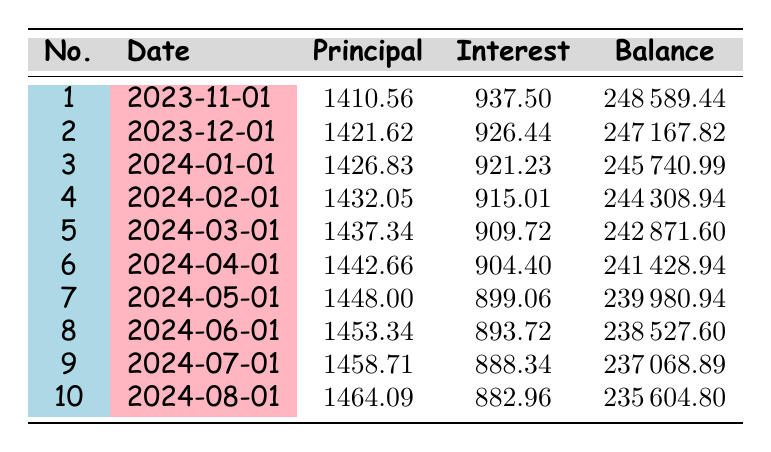What is the loan amount for the renovation? The loan amount is specifically stated in the loan details section, which indicates that the total amount borrowed is 250000.
Answer: 250000 What is the interest rate on the loan? The interest rate is also mentioned in the loan details, indicating that it is 4.5 percent.
Answer: 4.5 How much is the monthly payment? The monthly payment can be found in the loan details, which specifies that the payment amount is 1910.56.
Answer: 1910.56 Which payment number has the highest principal payment? To determine which payment number has the highest principal payment, we need to look at the principal payment column of the table. The payments increase each month, and by reviewing the data, the 10th payment is the highest at 1464.09.
Answer: 10 What is the total principal paid after the first three payments? We add the principal payments of the first three payments: 1410.56 + 1421.62 + 1426.83 = 4259.01.
Answer: 4259.01 Does the interest payment decrease with each payment? By examining the interest payment column, we notice that the amounts decrease each month, confirming that the interest payment becomes smaller over time as the principal is paid down.
Answer: Yes What is the remaining balance after the fifth payment? The remaining balance after the fifth payment can be found in the table, which lists 242871.60 as the balance after the fifth payment.
Answer: 242871.60 What is the average principal payment of the first ten payments? We calculate the average by summing the principal payments of the first ten payments: (1410.56 + 1421.62 + 1426.83 + 1432.05 + 1437.34 + 1442.66 + 1448.00 + 1453.34 + 1458.71 + 1464.09) = 1447.24, and then divide by the number of payments, which is 10. This gives us 1447.24 as the average.
Answer: 1447.24 How much interest is paid in the first payment? The interest paid in the first payment can be directly referenced from the interest payment column showing it as 937.50.
Answer: 937.50 What is the total remaining balance after the first six payments? To find the total remaining balance, we look at the remaining balance after the sixth payment in the table, which shows a balance of 241428.94 after that payment.
Answer: 241428.94 